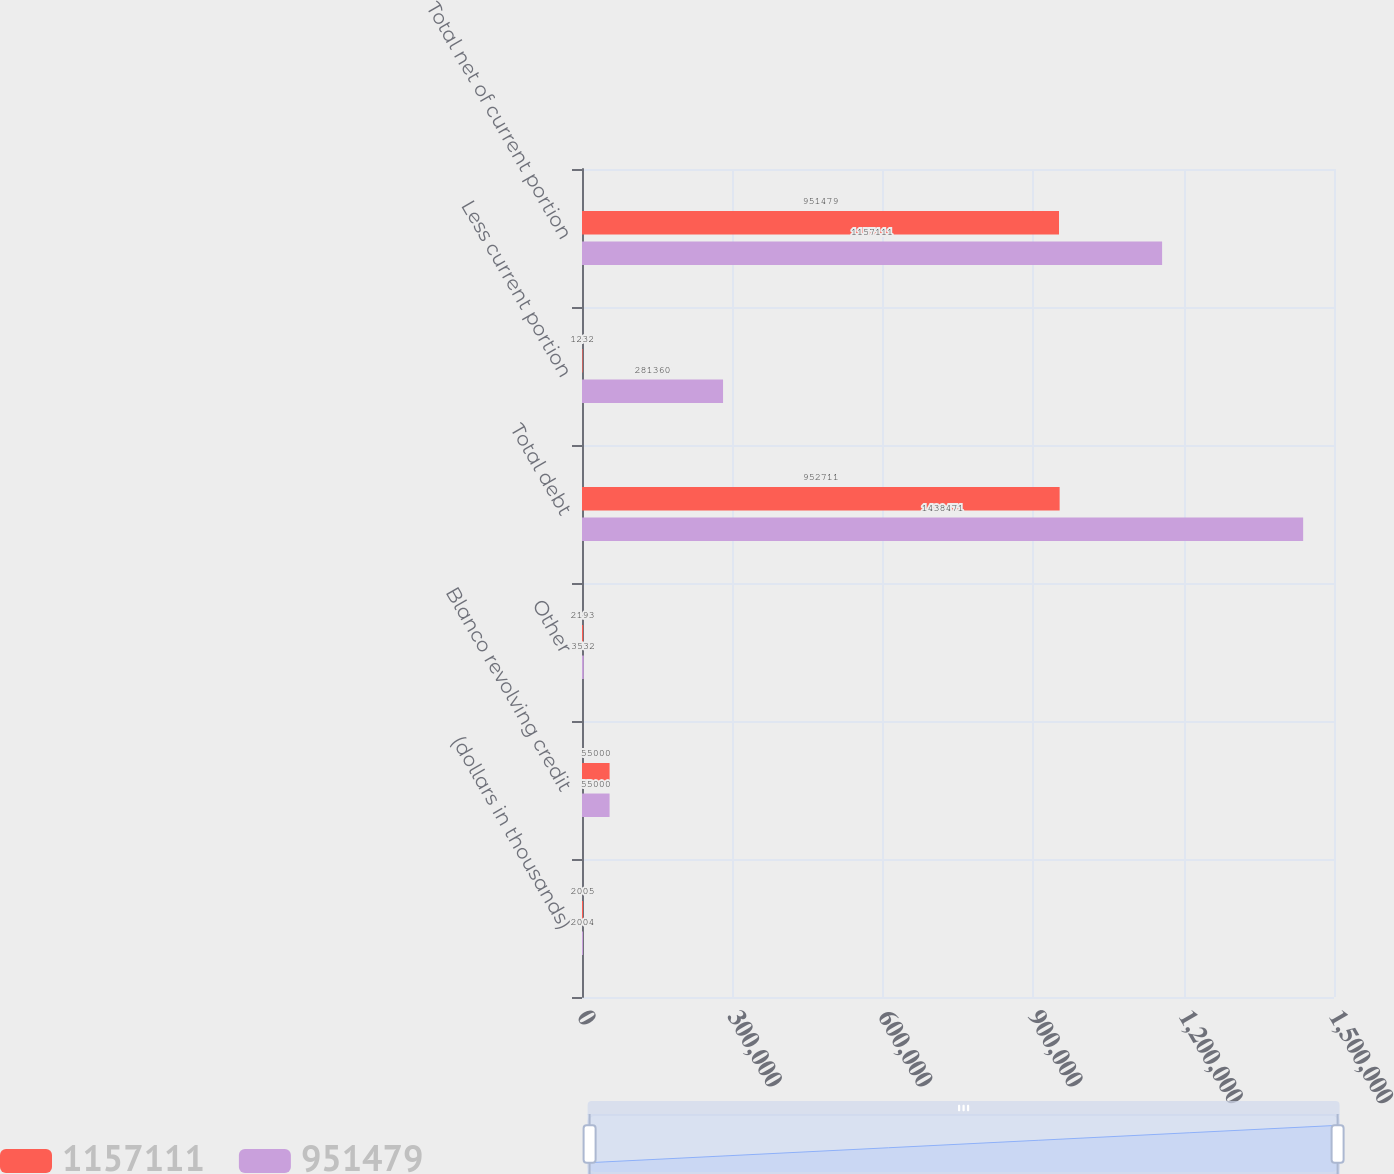Convert chart. <chart><loc_0><loc_0><loc_500><loc_500><stacked_bar_chart><ecel><fcel>(dollars in thousands)<fcel>Blanco revolving credit<fcel>Other<fcel>Total debt<fcel>Less current portion<fcel>Total net of current portion<nl><fcel>1.15711e+06<fcel>2005<fcel>55000<fcel>2193<fcel>952711<fcel>1232<fcel>951479<nl><fcel>951479<fcel>2004<fcel>55000<fcel>3532<fcel>1.43847e+06<fcel>281360<fcel>1.15711e+06<nl></chart> 